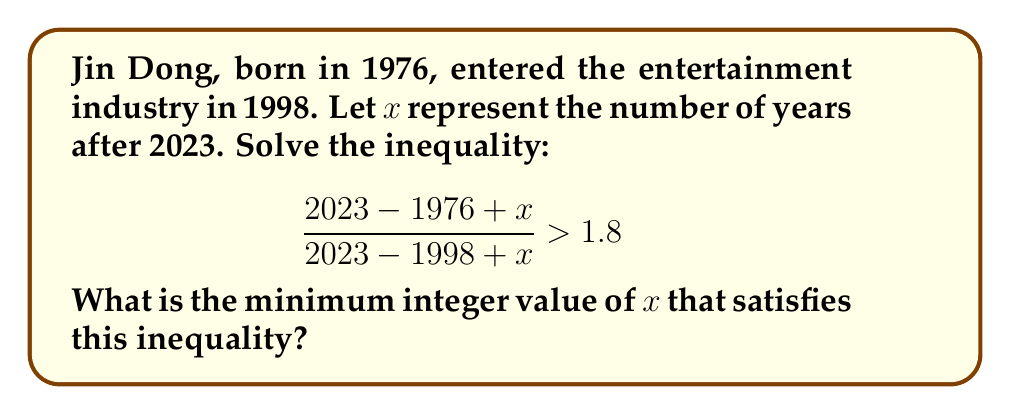Can you answer this question? Let's solve this step-by-step:

1) First, let's simplify the fractions in the inequality:
   $$\frac{47 + x}{25 + x} > 1.8$$

2) Multiply both sides by $(25 + x)$:
   $$(47 + x) > 1.8(25 + x)$$

3) Distribute on the right side:
   $$47 + x > 45 + 1.8x$$

4) Subtract 47 from both sides:
   $$x > -2 + 1.8x$$

5) Subtract $1.8x$ from both sides:
   $$-0.8x > -2$$

6) Divide both sides by -0.8 (remember to flip the inequality sign when dividing by a negative number):
   $$x < 2.5$$

7) Since we're looking for the minimum integer value of $x$, and $x$ must be less than 2.5, the largest integer that satisfies this is 2.

Therefore, the minimum integer value of $x$ that satisfies the inequality is 2.
Answer: 2 